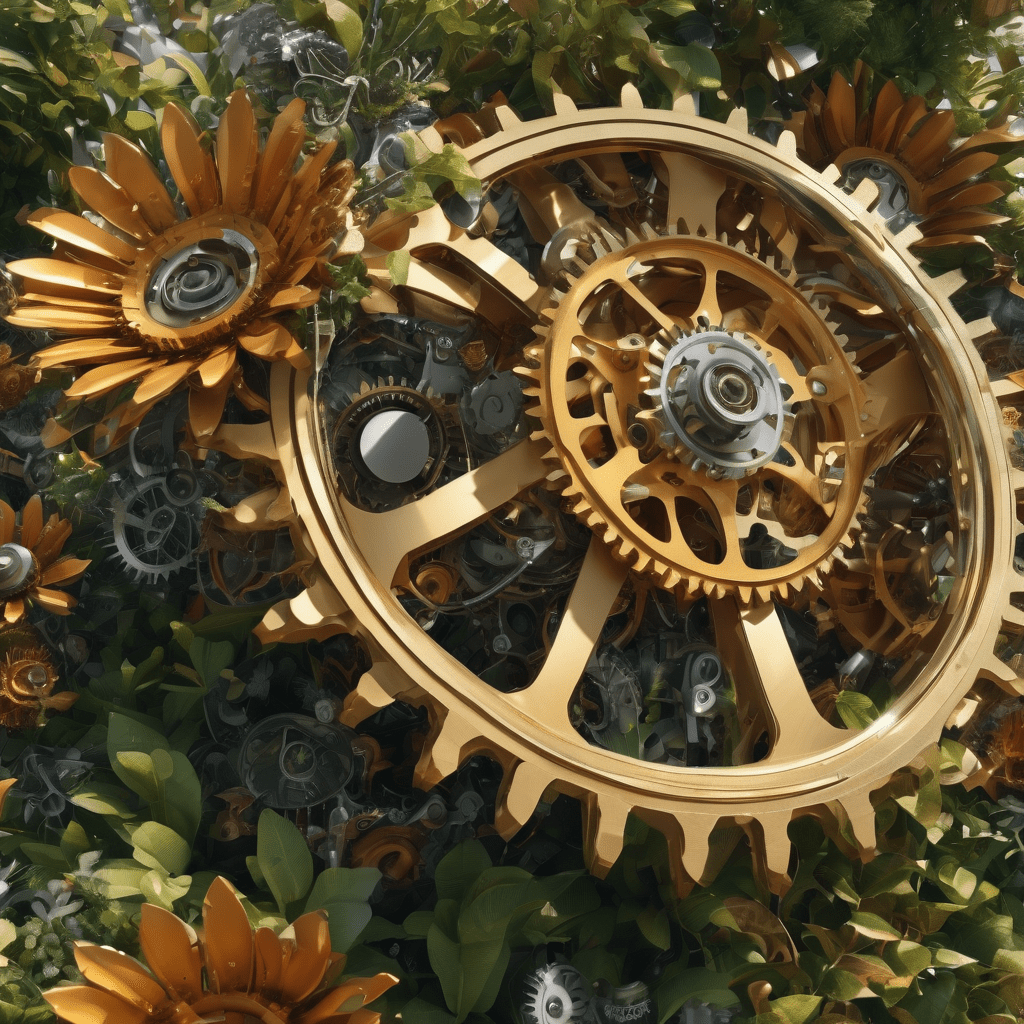What style of clothes does the person on the right sell ? The person on the right is likely involved in selling traditional Indian clothing. The shop in the background has racks of colorful garments, such as sarees, lehengas, and other traditional wear. What is this art style?
 This art style is known as "steampunk." Steampunk combines elements of science fiction and fantasy with design aesthetics inspired by 19th-century industrial steam-powered machinery. In this image, you can see a blend of mechanical gears and natural elements like flowers, which is characteristic of the steampunk style. 